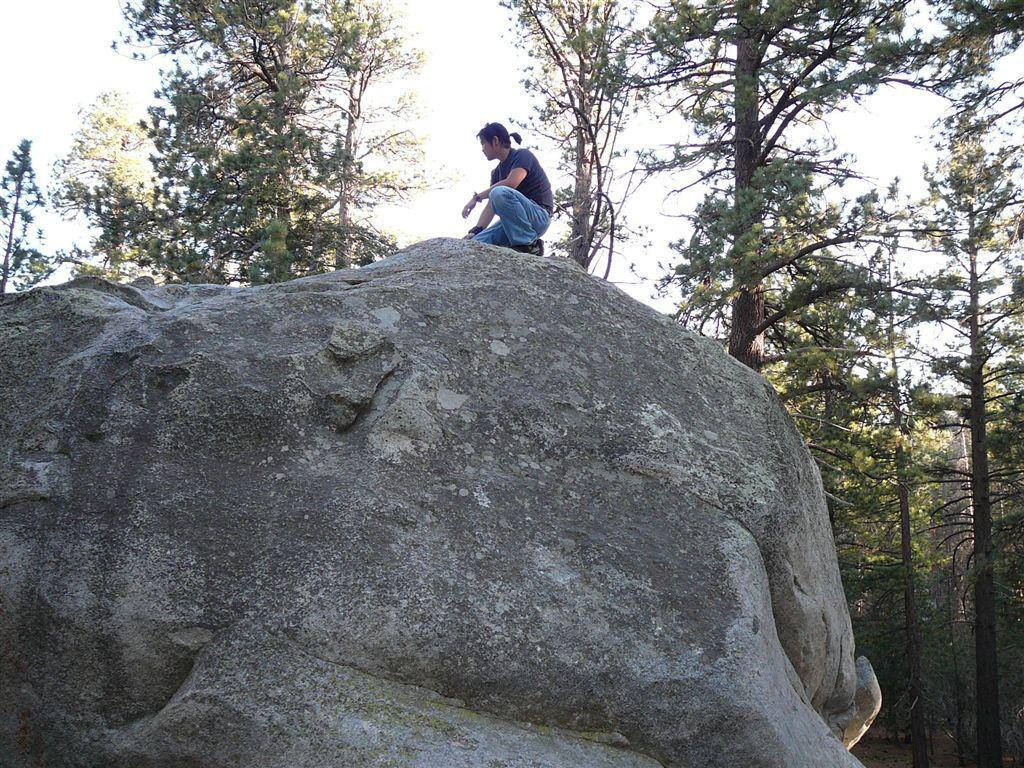Who is present in the image? There is a man in the image. What is the man doing in the image? The man is sitting on a big rock. Where is the rock located in the image? The rock is in the center of the image. What can be seen in the background of the image? There are trees and the sky visible in the background of the image. What type of voice can be heard coming from the crow in the image? There is no crow present in the image, so it is not possible to determine what type of voice might be heard. 